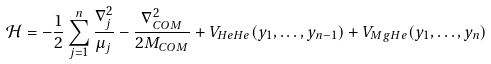<formula> <loc_0><loc_0><loc_500><loc_500>\mathcal { H } = - \frac { 1 } { 2 } \sum _ { j = 1 } ^ { n } \frac { \nabla _ { j } ^ { 2 } } { \mu _ { j } } - \frac { \nabla _ { C O M } ^ { 2 } } { 2 M _ { C O M } } + V _ { H e H e } ( y _ { 1 } , \dots , y _ { n - 1 } ) + V _ { M g H e } ( y _ { 1 } , \dots , y _ { n } )</formula> 